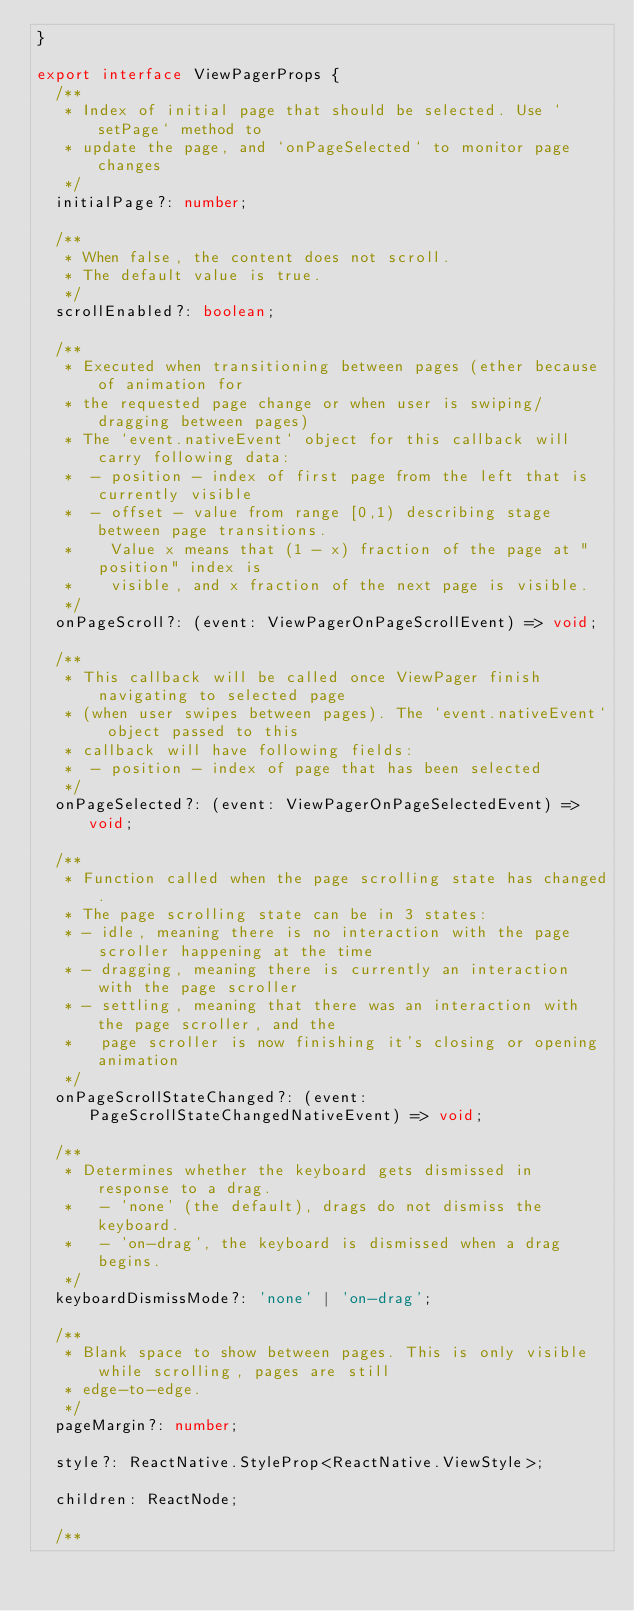Convert code to text. <code><loc_0><loc_0><loc_500><loc_500><_TypeScript_>}

export interface ViewPagerProps {
  /**
   * Index of initial page that should be selected. Use `setPage` method to
   * update the page, and `onPageSelected` to monitor page changes
   */
  initialPage?: number;

  /**
   * When false, the content does not scroll.
   * The default value is true.
   */
  scrollEnabled?: boolean;

  /**
   * Executed when transitioning between pages (ether because of animation for
   * the requested page change or when user is swiping/dragging between pages)
   * The `event.nativeEvent` object for this callback will carry following data:
   *  - position - index of first page from the left that is currently visible
   *  - offset - value from range [0,1) describing stage between page transitions.
   *    Value x means that (1 - x) fraction of the page at "position" index is
   *    visible, and x fraction of the next page is visible.
   */
  onPageScroll?: (event: ViewPagerOnPageScrollEvent) => void;

  /**
   * This callback will be called once ViewPager finish navigating to selected page
   * (when user swipes between pages). The `event.nativeEvent` object passed to this
   * callback will have following fields:
   *  - position - index of page that has been selected
   */
  onPageSelected?: (event: ViewPagerOnPageSelectedEvent) => void;

  /**
   * Function called when the page scrolling state has changed.
   * The page scrolling state can be in 3 states:
   * - idle, meaning there is no interaction with the page scroller happening at the time
   * - dragging, meaning there is currently an interaction with the page scroller
   * - settling, meaning that there was an interaction with the page scroller, and the
   *   page scroller is now finishing it's closing or opening animation
   */
  onPageScrollStateChanged?: (event: PageScrollStateChangedNativeEvent) => void;

  /**
   * Determines whether the keyboard gets dismissed in response to a drag.
   *   - 'none' (the default), drags do not dismiss the keyboard.
   *   - 'on-drag', the keyboard is dismissed when a drag begins.
   */
  keyboardDismissMode?: 'none' | 'on-drag';

  /**
   * Blank space to show between pages. This is only visible while scrolling, pages are still
   * edge-to-edge.
   */
  pageMargin?: number;

  style?: ReactNative.StyleProp<ReactNative.ViewStyle>;

  children: ReactNode;

  /**</code> 